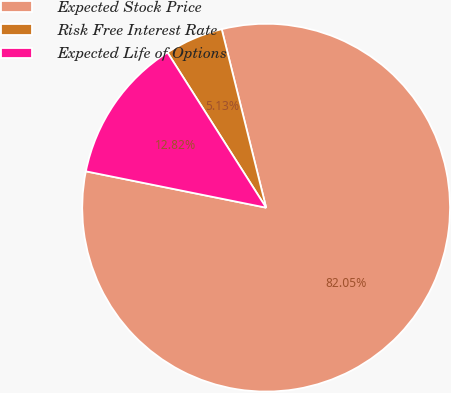<chart> <loc_0><loc_0><loc_500><loc_500><pie_chart><fcel>Expected Stock Price<fcel>Risk Free Interest Rate<fcel>Expected Life of Options<nl><fcel>82.05%<fcel>5.13%<fcel>12.82%<nl></chart> 